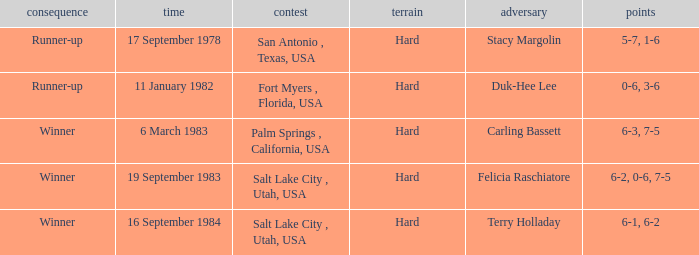What was the outcome of the match against Stacy Margolin? Runner-up. 